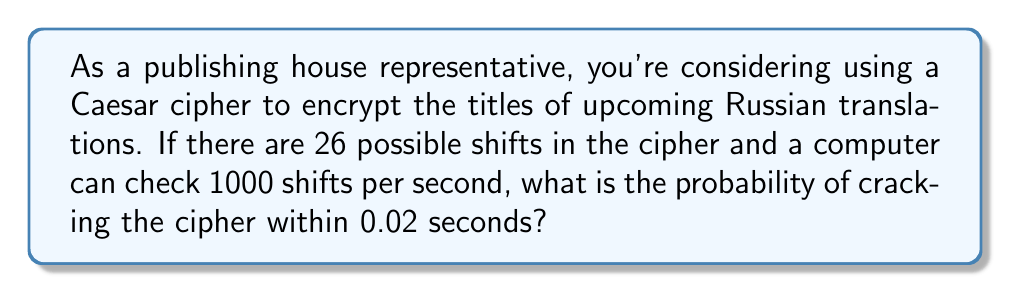Teach me how to tackle this problem. Let's approach this step-by-step:

1) First, we need to calculate how many shifts the computer can check in 0.02 seconds:
   $$\text{Shifts checked} = \text{Rate} \times \text{Time}$$
   $$\text{Shifts checked} = 1000 \text{ shifts/second} \times 0.02 \text{ seconds} = 20 \text{ shifts}$$

2) Now, we need to determine the probability of success. This is equivalent to the probability of guessing the correct shift within the first 20 tries out of 26 possible shifts.

3) The probability of success is:
   $$P(\text{success}) = \frac{\text{Favorable outcomes}}{\text{Total outcomes}} = \frac{20}{26}$$

4) To simplify this fraction:
   $$\frac{20}{26} = \frac{10}{13} \approx 0.7692$$

5) Therefore, the probability of cracking the Caesar cipher within 0.02 seconds is $\frac{10}{13}$ or approximately 0.7692 or 76.92%.
Answer: $\frac{10}{13}$ 